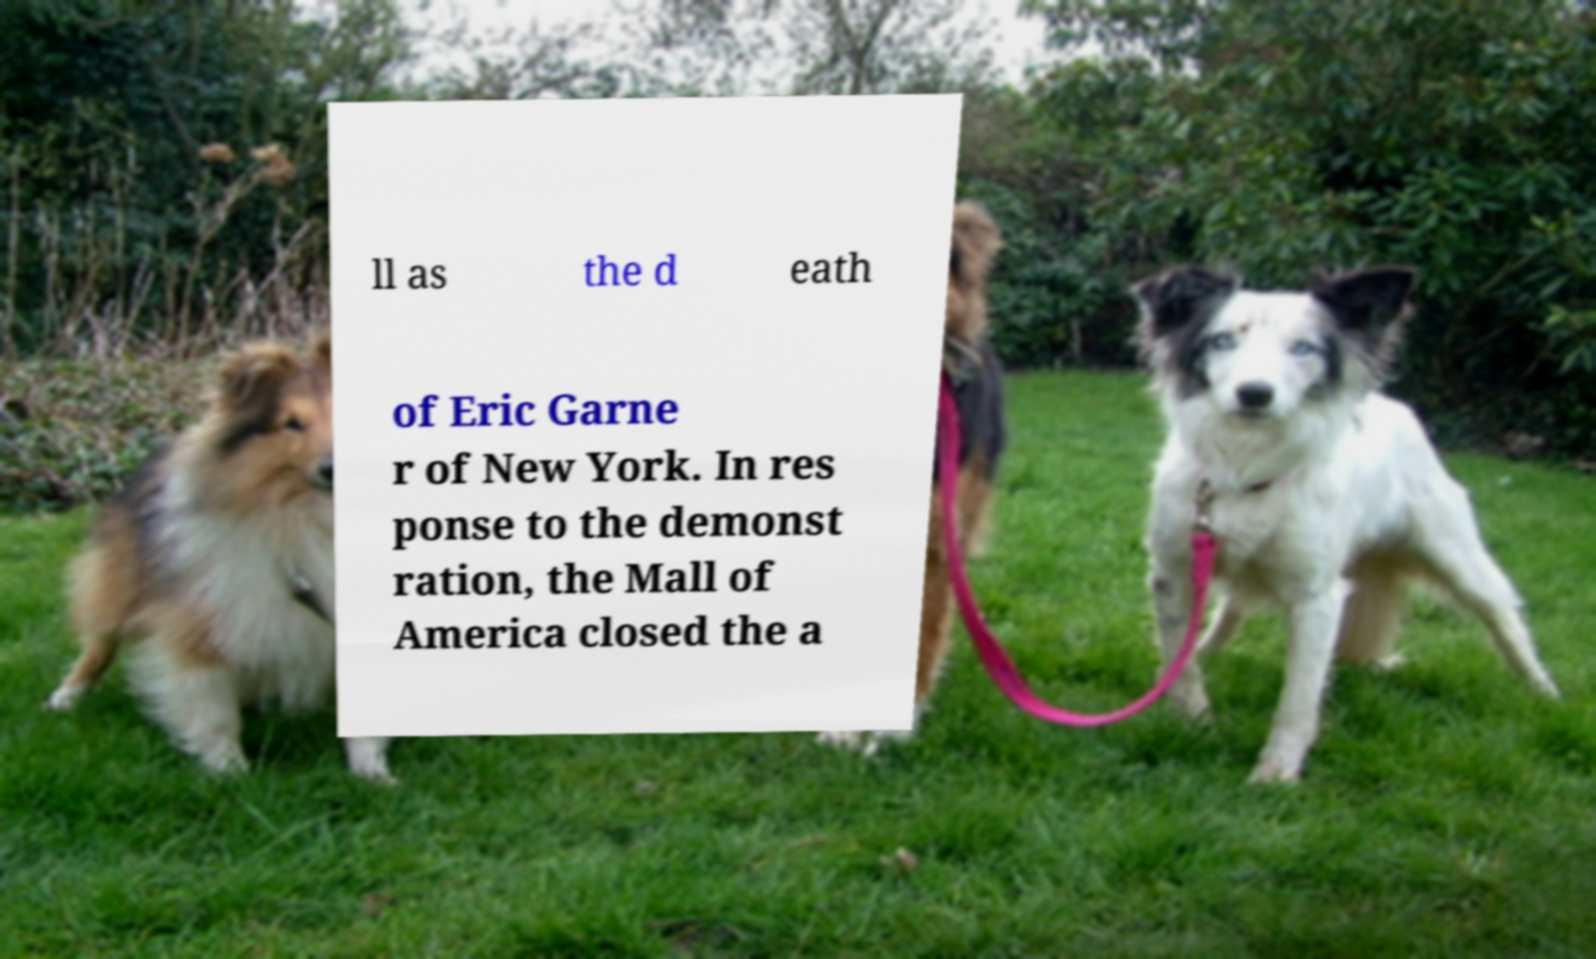For documentation purposes, I need the text within this image transcribed. Could you provide that? ll as the d eath of Eric Garne r of New York. In res ponse to the demonst ration, the Mall of America closed the a 